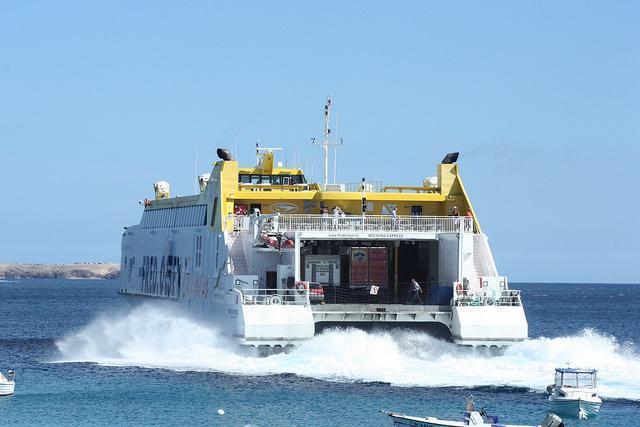How many boats are visible?
Give a very brief answer. 2. 